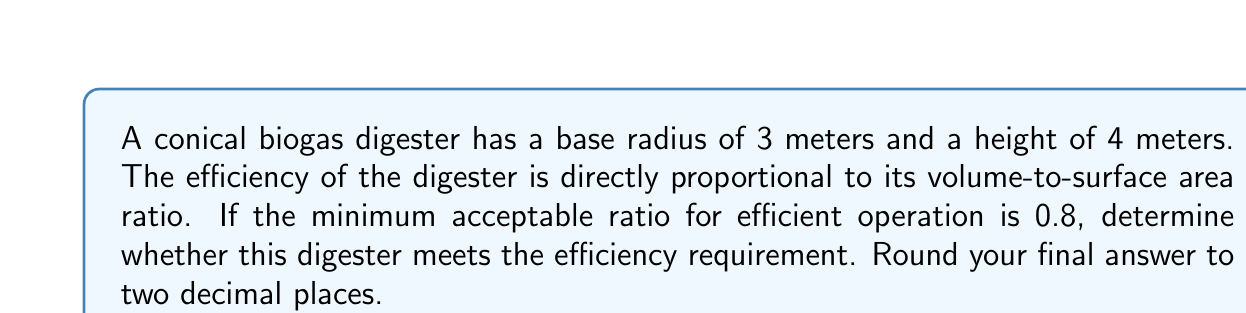Solve this math problem. To solve this problem, we need to follow these steps:

1. Calculate the volume of the conical digester
2. Calculate the surface area of the conical digester
3. Find the volume-to-surface area ratio
4. Compare the ratio to the minimum requirement

Step 1: Calculate the volume of the conical digester
The volume of a cone is given by the formula:
$$ V = \frac{1}{3}\pi r^2 h $$
where $r$ is the radius of the base and $h$ is the height.

$$ V = \frac{1}{3}\pi (3\text{ m})^2 (4\text{ m}) = \frac{1}{3}\pi (9\text{ m}^2) (4\text{ m}) = 12\pi\text{ m}^3 $$

Step 2: Calculate the surface area of the conical digester
The surface area of a cone consists of the circular base area and the lateral surface area:
$$ SA = \pi r^2 + \pi r s $$
where $s$ is the slant height of the cone.

To find the slant height, we use the Pythagorean theorem:
$$ s = \sqrt{r^2 + h^2} = \sqrt{3^2 + 4^2} = \sqrt{9 + 16} = \sqrt{25} = 5\text{ m} $$

Now we can calculate the surface area:
$$ SA = \pi (3\text{ m})^2 + \pi (3\text{ m})(5\text{ m}) = 9\pi\text{ m}^2 + 15\pi\text{ m}^2 = 24\pi\text{ m}^2 $$

Step 3: Find the volume-to-surface area ratio
$$ \text{Ratio} = \frac{\text{Volume}}{\text{Surface Area}} = \frac{12\pi\text{ m}^3}{24\pi\text{ m}^2} = \frac{1}{2}\text{ m} = 0.5\text{ m} $$

Step 4: Compare the ratio to the minimum requirement
The calculated ratio (0.5 m) is less than the minimum acceptable ratio (0.8 m).
Answer: The volume-to-surface area ratio is 0.50 m, which is below the minimum acceptable ratio of 0.8 m. Therefore, this conical biogas digester does not meet the efficiency requirement. 